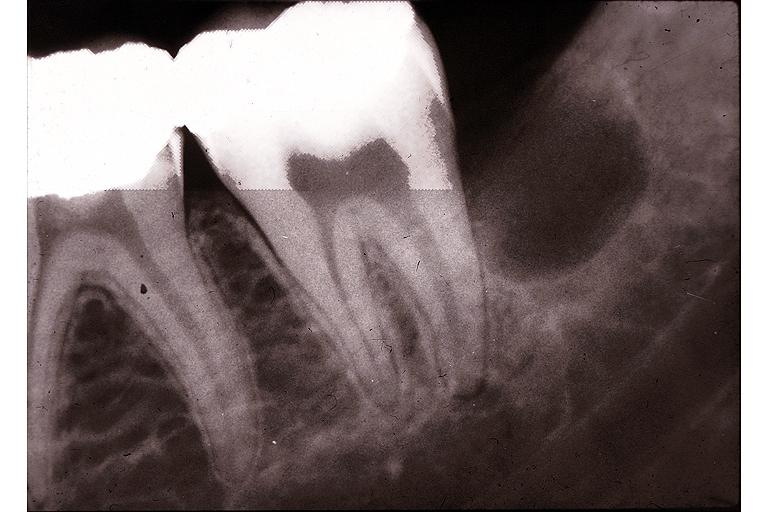s ulcer with candida infection present?
Answer the question using a single word or phrase. No 